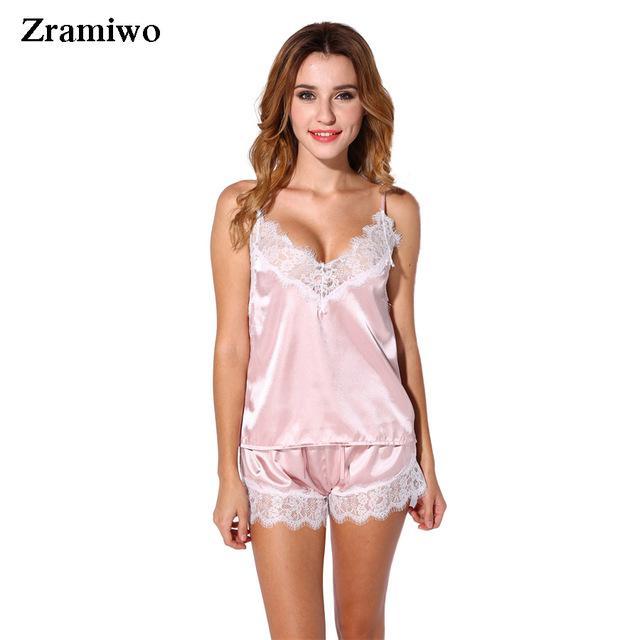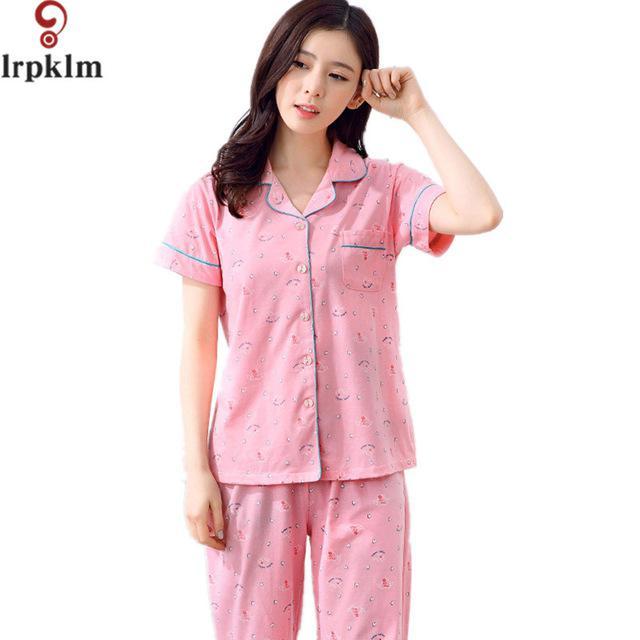The first image is the image on the left, the second image is the image on the right. For the images displayed, is the sentence "A woman is wearing a silky shiny pink sleepwear." factually correct? Answer yes or no. Yes. The first image is the image on the left, the second image is the image on the right. Examine the images to the left and right. Is the description "One model is wearing a shiny pink matching camisole top and short shorts." accurate? Answer yes or no. Yes. 